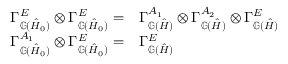<formula> <loc_0><loc_0><loc_500><loc_500>\begin{array} { r } { \begin{array} { r l } { \Gamma _ { \mathbb { G } ( \hat { H } _ { 0 } ) } ^ { E } \otimes \Gamma _ { \mathbb { G } ( \hat { H } _ { 0 } ) } ^ { E } = } & { \Gamma _ { \mathbb { G } ( \hat { H } ) } ^ { A _ { 1 } } \otimes \Gamma _ { \mathbb { G } ( \hat { H } ) } ^ { A _ { 2 } } \otimes \Gamma _ { \mathbb { G } ( \hat { H } ) } ^ { E } } \\ { \Gamma _ { \mathbb { G } ( \hat { H } _ { 0 } ) } ^ { A _ { 1 } } \otimes \Gamma _ { \mathbb { G } ( \hat { H } _ { 0 } ) } ^ { E } = } & { \Gamma _ { \mathbb { G } ( \hat { H } ) } ^ { E } } \end{array} } \end{array}</formula> 